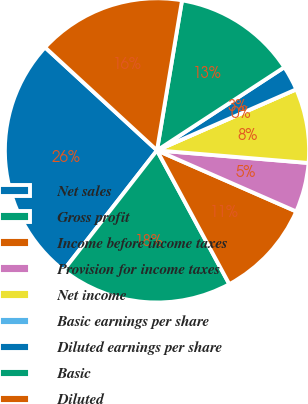<chart> <loc_0><loc_0><loc_500><loc_500><pie_chart><fcel>Net sales<fcel>Gross profit<fcel>Income before income taxes<fcel>Provision for income taxes<fcel>Net income<fcel>Basic earnings per share<fcel>Diluted earnings per share<fcel>Basic<fcel>Diluted<nl><fcel>26.31%<fcel>18.42%<fcel>10.53%<fcel>5.26%<fcel>7.9%<fcel>0.0%<fcel>2.63%<fcel>13.16%<fcel>15.79%<nl></chart> 